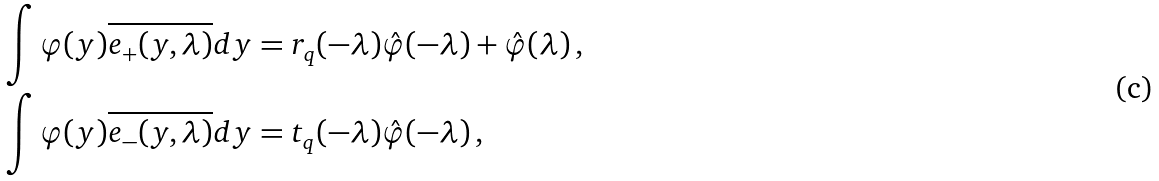Convert formula to latex. <formula><loc_0><loc_0><loc_500><loc_500>& \int \varphi ( y ) \overline { e _ { + } ( y , \lambda ) } d y = r _ { q } ( - \lambda ) \hat { \varphi } ( - \lambda ) + \hat { \varphi } ( \lambda ) \, , \\ & \int \varphi ( y ) \overline { e _ { - } ( y , \lambda ) } d y = t _ { q } ( - \lambda ) \hat { \varphi } ( - \lambda ) \, ,</formula> 